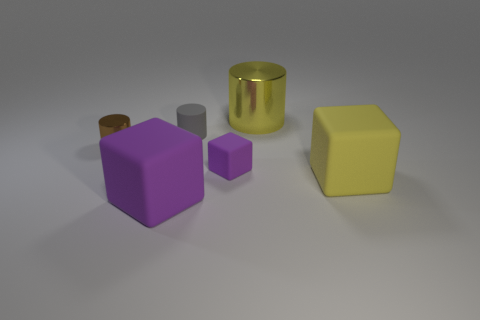Does the big cube that is right of the large purple matte thing have the same color as the metal cylinder to the right of the small cube?
Make the answer very short. Yes. What number of brown shiny blocks are the same size as the gray rubber object?
Give a very brief answer. 0. Is the material of the big yellow object that is right of the big yellow cylinder the same as the small purple cube?
Offer a terse response. Yes. Is the number of tiny rubber things on the right side of the gray object less than the number of shiny blocks?
Offer a very short reply. No. The metal object that is behind the brown cylinder has what shape?
Your answer should be very brief. Cylinder. There is a purple thing that is the same size as the gray matte cylinder; what is its shape?
Your answer should be compact. Cube. Are there any large purple things that have the same shape as the big yellow matte thing?
Provide a succinct answer. Yes. Do the rubber thing behind the small purple cube and the metal thing that is on the left side of the gray thing have the same shape?
Ensure brevity in your answer.  Yes. What material is the yellow cylinder that is the same size as the yellow matte block?
Keep it short and to the point. Metal. How many other things are the same material as the small gray object?
Offer a very short reply. 3. 